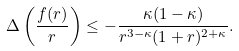<formula> <loc_0><loc_0><loc_500><loc_500>\Delta \left ( \frac { f ( r ) } { r } \right ) \leq - \frac { \kappa ( 1 - \kappa ) } { r ^ { 3 - \kappa } ( 1 + r ) ^ { 2 + \kappa } } .</formula> 